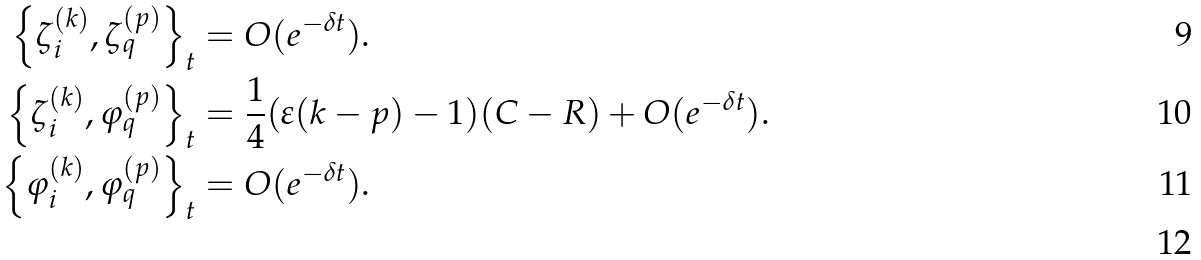<formula> <loc_0><loc_0><loc_500><loc_500>\left \{ \zeta _ { i } ^ { ( k ) } , \zeta _ { q } ^ { ( p ) } \right \} _ { t } & = O ( e ^ { - \delta t } ) . \\ \left \{ \zeta _ { i } ^ { ( k ) } , \varphi _ { q } ^ { ( p ) } \right \} _ { t } & = \frac { 1 } { 4 } ( \varepsilon ( k - p ) - 1 ) ( C - R ) + O ( e ^ { - \delta t } ) . \\ \left \{ \varphi _ { i } ^ { ( k ) } , \varphi _ { q } ^ { ( p ) } \right \} _ { t } & = O ( e ^ { - \delta t } ) . \\</formula> 